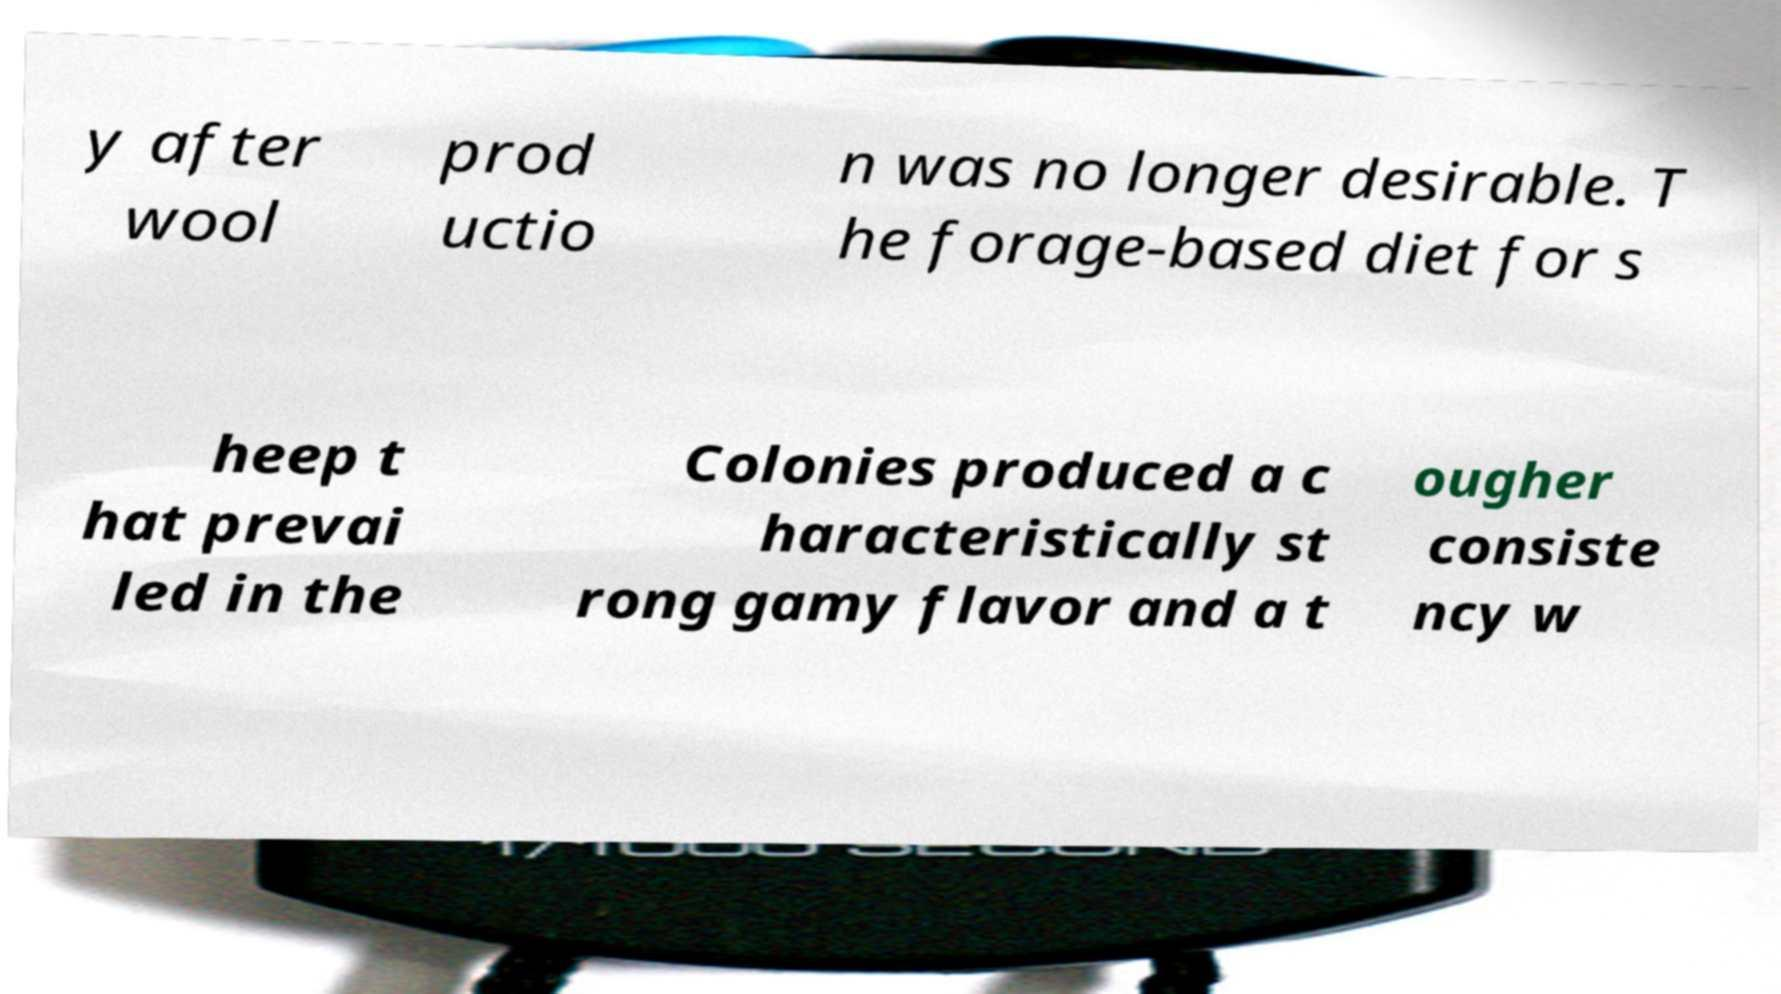There's text embedded in this image that I need extracted. Can you transcribe it verbatim? y after wool prod uctio n was no longer desirable. T he forage-based diet for s heep t hat prevai led in the Colonies produced a c haracteristically st rong gamy flavor and a t ougher consiste ncy w 